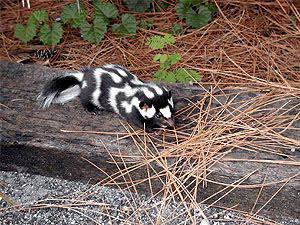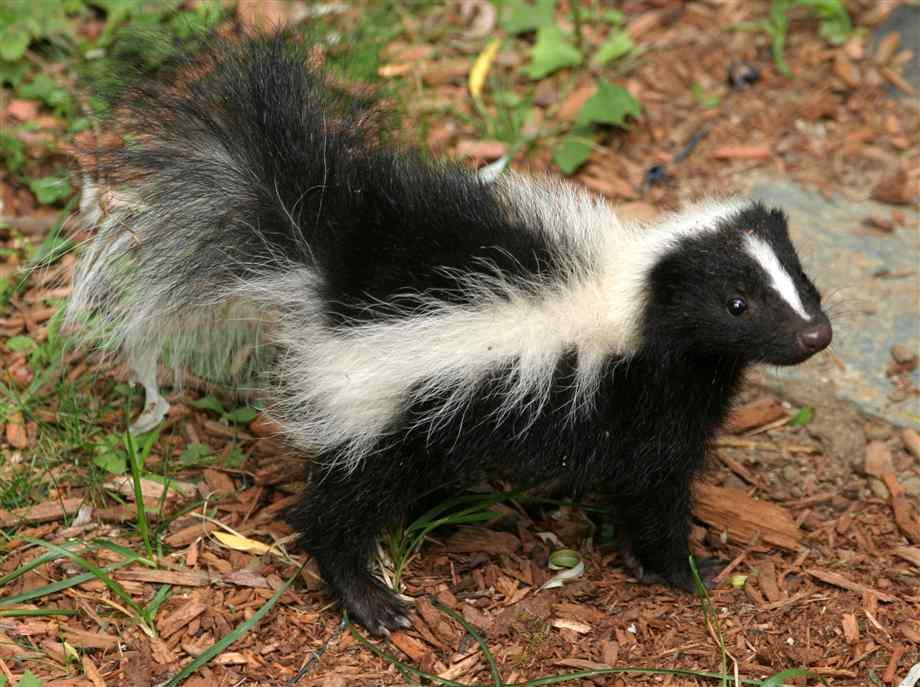The first image is the image on the left, the second image is the image on the right. Evaluate the accuracy of this statement regarding the images: "One tail is a solid color.". Is it true? Answer yes or no. No. The first image is the image on the left, the second image is the image on the right. Analyze the images presented: Is the assertion "The single skunk on the right has a bold straight white stripe and stands in profile, and the single skunk on the left has curving, maze-like stripes." valid? Answer yes or no. Yes. 